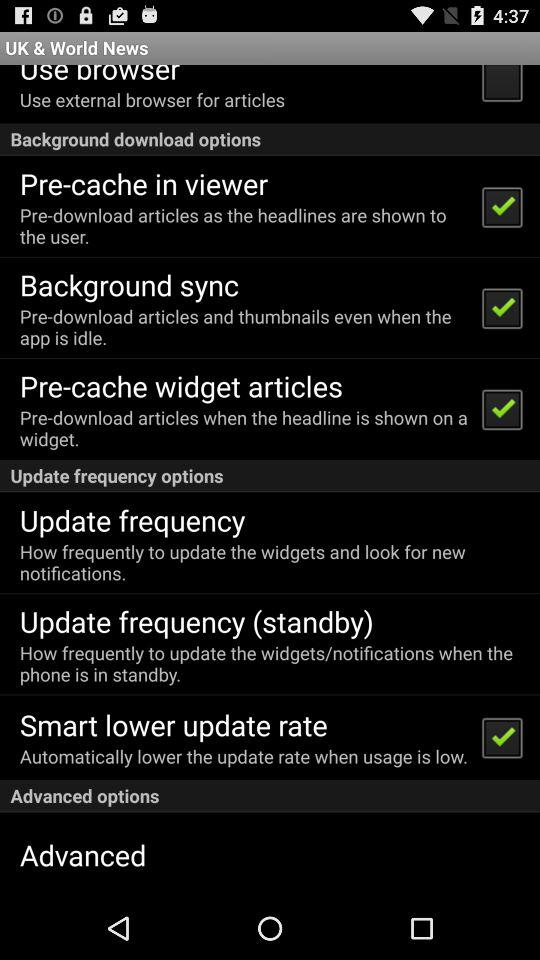Which option is not marked as checked? The option "Use browser" is not marked as checked. 